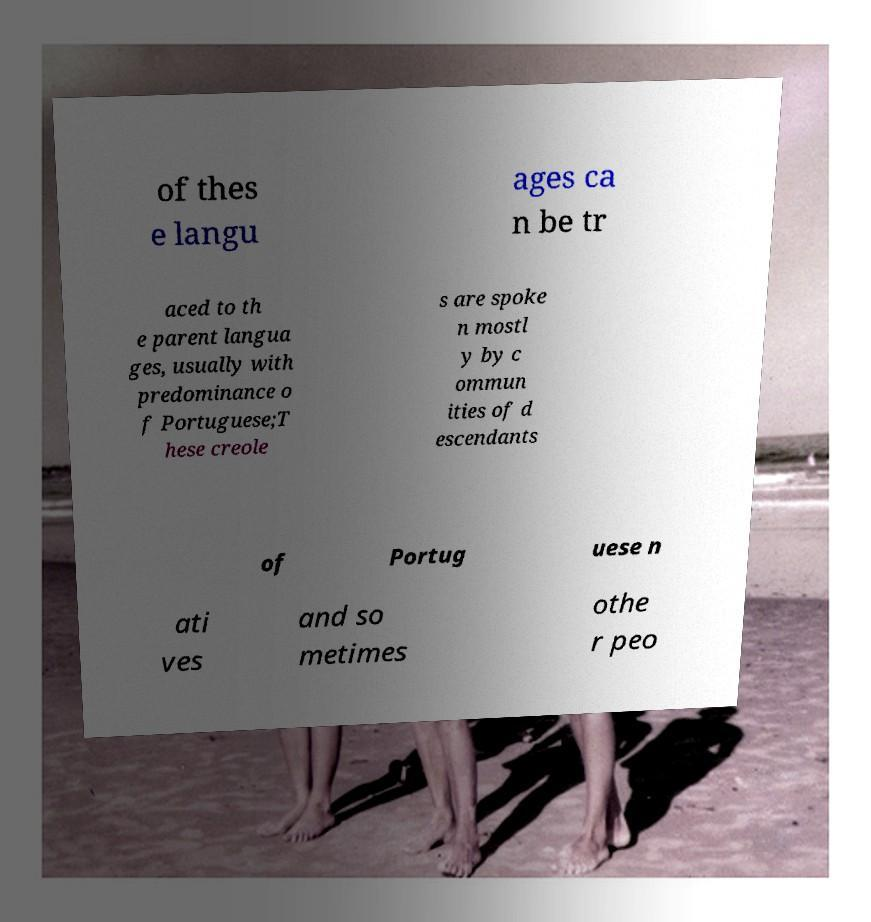What messages or text are displayed in this image? I need them in a readable, typed format. of thes e langu ages ca n be tr aced to th e parent langua ges, usually with predominance o f Portuguese;T hese creole s are spoke n mostl y by c ommun ities of d escendants of Portug uese n ati ves and so metimes othe r peo 